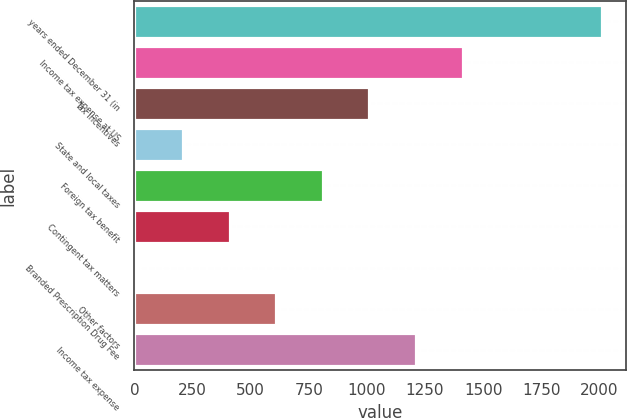Convert chart to OTSL. <chart><loc_0><loc_0><loc_500><loc_500><bar_chart><fcel>years ended December 31 (in<fcel>Income tax expense at US<fcel>Tax incentives<fcel>State and local taxes<fcel>Foreign tax benefit<fcel>Contingent tax matters<fcel>Branded Prescription Drug Fee<fcel>Other factors<fcel>Income tax expense<nl><fcel>2013<fcel>1411.8<fcel>1011<fcel>209.4<fcel>810.6<fcel>409.8<fcel>9<fcel>610.2<fcel>1211.4<nl></chart> 